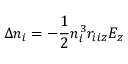<formula> <loc_0><loc_0><loc_500><loc_500>\Delta n _ { i } = - \frac { 1 } { 2 } n _ { i } ^ { 3 } r _ { i i z } E _ { z }</formula> 